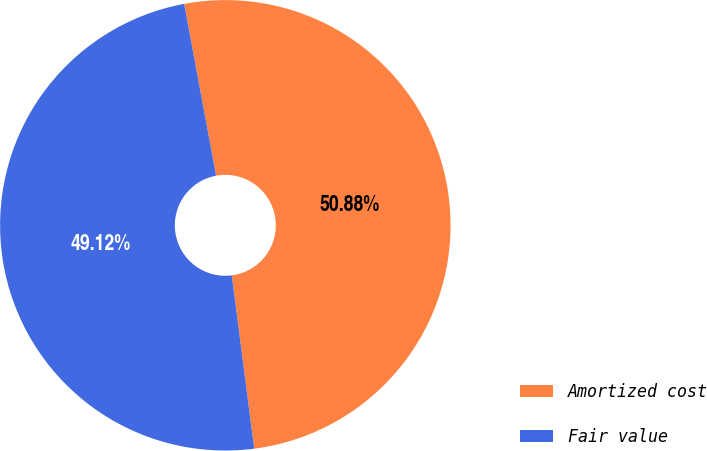<chart> <loc_0><loc_0><loc_500><loc_500><pie_chart><fcel>Amortized cost<fcel>Fair value<nl><fcel>50.88%<fcel>49.12%<nl></chart> 